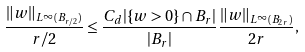Convert formula to latex. <formula><loc_0><loc_0><loc_500><loc_500>\frac { \| w \| _ { L ^ { \infty } ( B _ { r / 2 } ) } } { r / 2 } \leq \frac { C _ { d } | \{ w > 0 \} \cap B _ { r } | } { | B _ { r } | } \frac { \| w \| _ { L ^ { \infty } ( B _ { 2 r } ) } } { 2 r } ,</formula> 